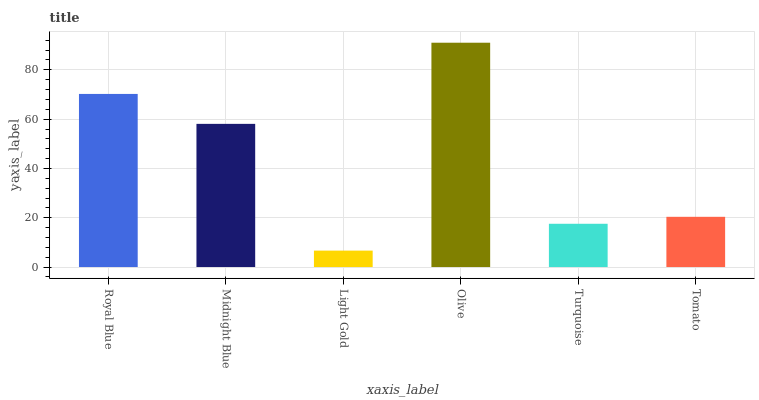Is Midnight Blue the minimum?
Answer yes or no. No. Is Midnight Blue the maximum?
Answer yes or no. No. Is Royal Blue greater than Midnight Blue?
Answer yes or no. Yes. Is Midnight Blue less than Royal Blue?
Answer yes or no. Yes. Is Midnight Blue greater than Royal Blue?
Answer yes or no. No. Is Royal Blue less than Midnight Blue?
Answer yes or no. No. Is Midnight Blue the high median?
Answer yes or no. Yes. Is Tomato the low median?
Answer yes or no. Yes. Is Light Gold the high median?
Answer yes or no. No. Is Midnight Blue the low median?
Answer yes or no. No. 